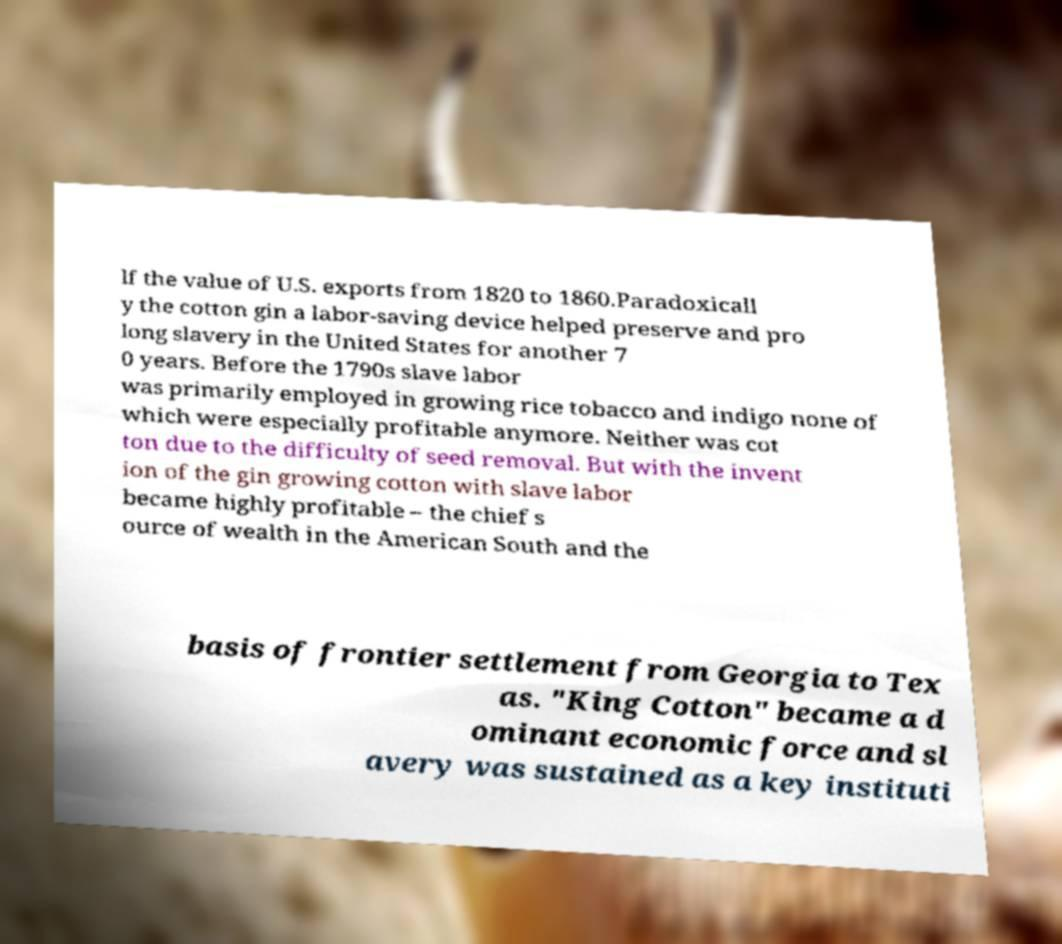Could you assist in decoding the text presented in this image and type it out clearly? lf the value of U.S. exports from 1820 to 1860.Paradoxicall y the cotton gin a labor-saving device helped preserve and pro long slavery in the United States for another 7 0 years. Before the 1790s slave labor was primarily employed in growing rice tobacco and indigo none of which were especially profitable anymore. Neither was cot ton due to the difficulty of seed removal. But with the invent ion of the gin growing cotton with slave labor became highly profitable – the chief s ource of wealth in the American South and the basis of frontier settlement from Georgia to Tex as. "King Cotton" became a d ominant economic force and sl avery was sustained as a key instituti 